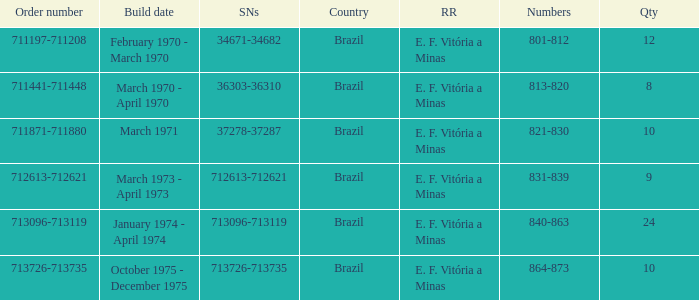What country has the order number 711871-711880? Brazil. 